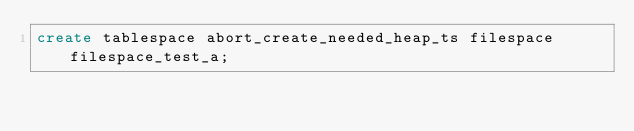<code> <loc_0><loc_0><loc_500><loc_500><_SQL_>create tablespace abort_create_needed_heap_ts filespace filespace_test_a;
</code> 